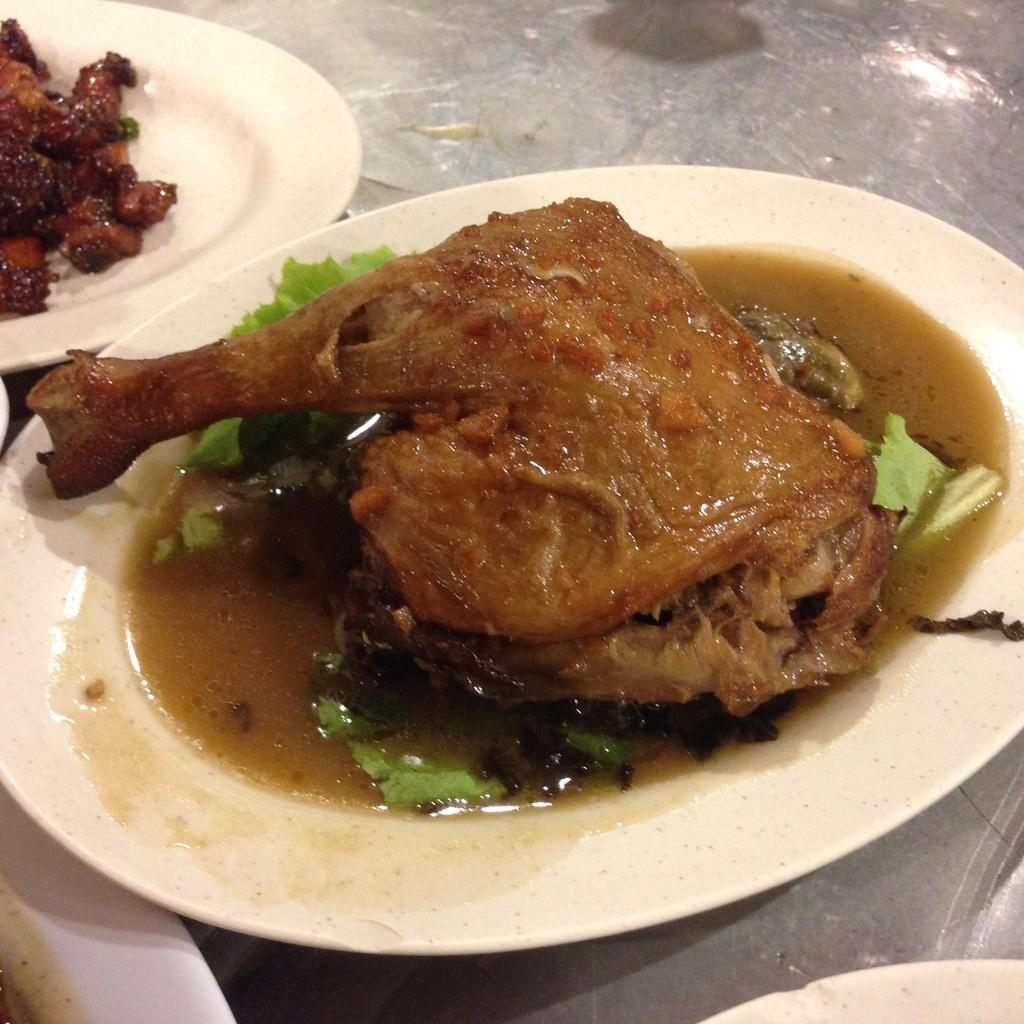What objects are present on the plates in the image? There are food items on the plates in the image. What is the location of the plates in the image? The plates are on a surface in the image. What type of farm can be seen in the image? There is no farm present in the image; it only features plates with food items on a surface. 